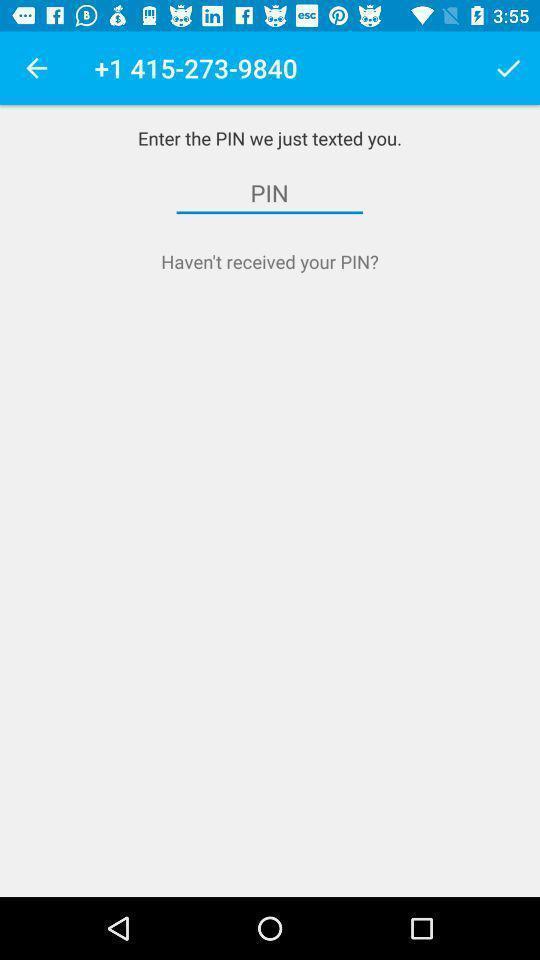What details can you identify in this image? Screen shows enter the pin option. 